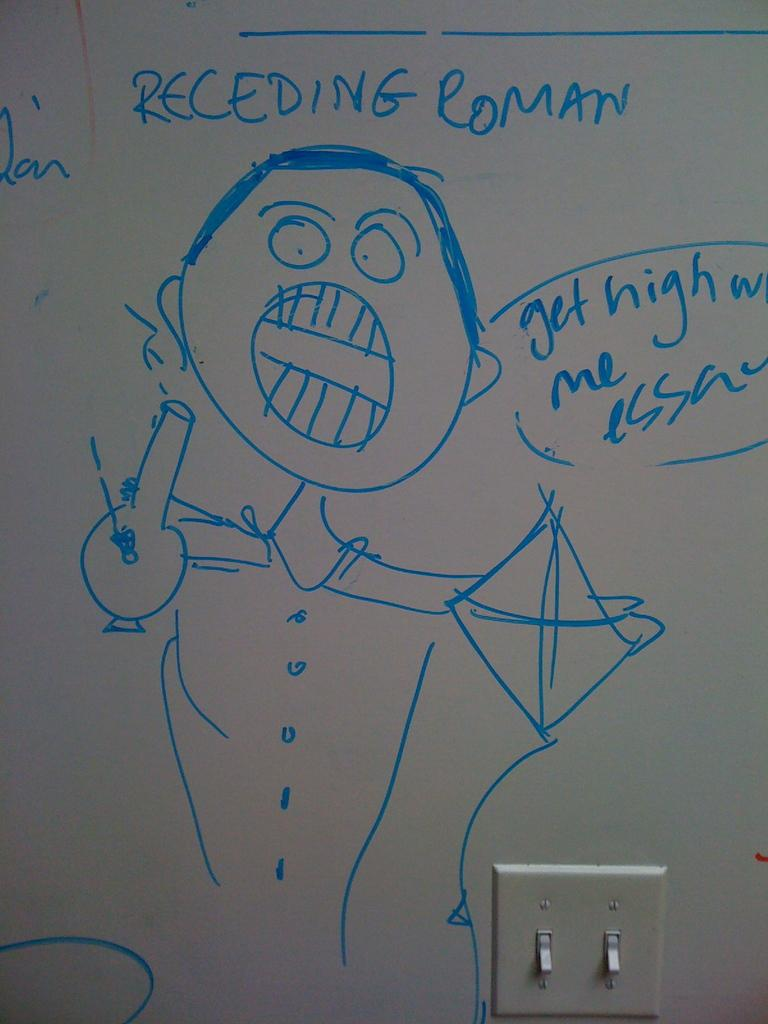<image>
Relay a brief, clear account of the picture shown. someone drew a picture on the white board of a man getting high 